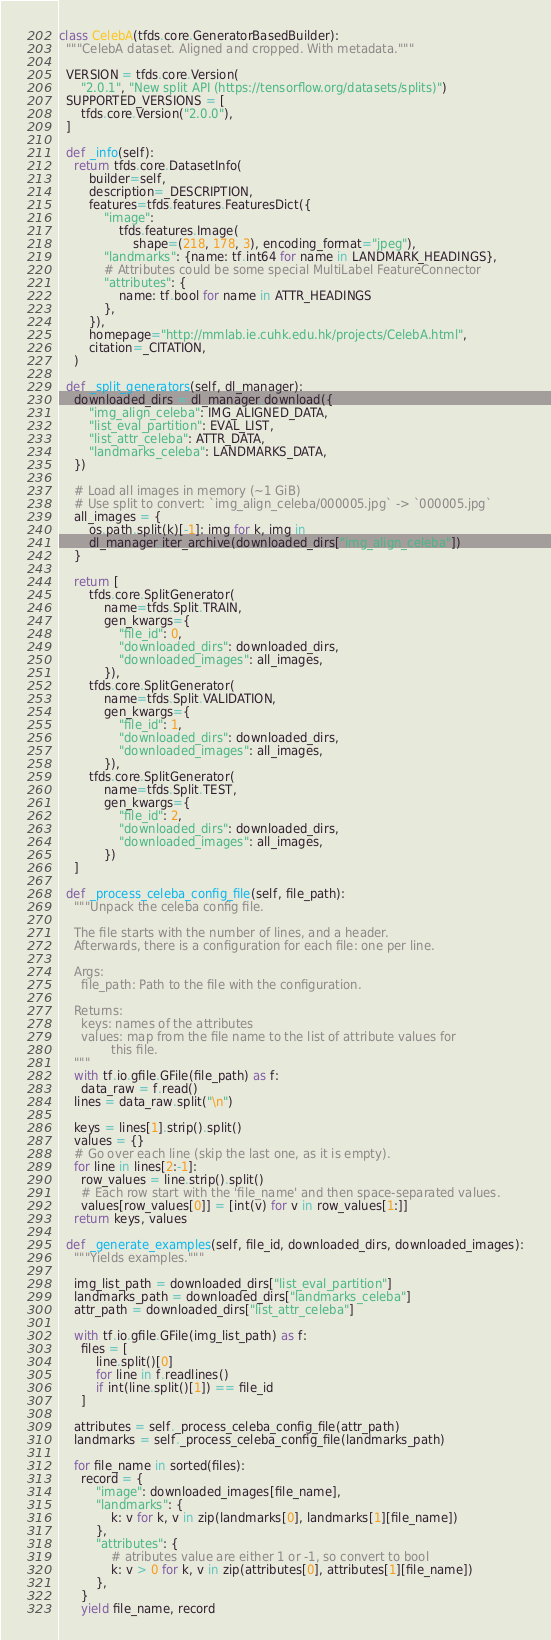Convert code to text. <code><loc_0><loc_0><loc_500><loc_500><_Python_>

class CelebA(tfds.core.GeneratorBasedBuilder):
  """CelebA dataset. Aligned and cropped. With metadata."""

  VERSION = tfds.core.Version(
      "2.0.1", "New split API (https://tensorflow.org/datasets/splits)")
  SUPPORTED_VERSIONS = [
      tfds.core.Version("2.0.0"),
  ]

  def _info(self):
    return tfds.core.DatasetInfo(
        builder=self,
        description=_DESCRIPTION,
        features=tfds.features.FeaturesDict({
            "image":
                tfds.features.Image(
                    shape=(218, 178, 3), encoding_format="jpeg"),
            "landmarks": {name: tf.int64 for name in LANDMARK_HEADINGS},
            # Attributes could be some special MultiLabel FeatureConnector
            "attributes": {
                name: tf.bool for name in ATTR_HEADINGS
            },
        }),
        homepage="http://mmlab.ie.cuhk.edu.hk/projects/CelebA.html",
        citation=_CITATION,
    )

  def _split_generators(self, dl_manager):
    downloaded_dirs = dl_manager.download({
        "img_align_celeba": IMG_ALIGNED_DATA,
        "list_eval_partition": EVAL_LIST,
        "list_attr_celeba": ATTR_DATA,
        "landmarks_celeba": LANDMARKS_DATA,
    })

    # Load all images in memory (~1 GiB)
    # Use split to convert: `img_align_celeba/000005.jpg` -> `000005.jpg`
    all_images = {
        os.path.split(k)[-1]: img for k, img in
        dl_manager.iter_archive(downloaded_dirs["img_align_celeba"])
    }

    return [
        tfds.core.SplitGenerator(
            name=tfds.Split.TRAIN,
            gen_kwargs={
                "file_id": 0,
                "downloaded_dirs": downloaded_dirs,
                "downloaded_images": all_images,
            }),
        tfds.core.SplitGenerator(
            name=tfds.Split.VALIDATION,
            gen_kwargs={
                "file_id": 1,
                "downloaded_dirs": downloaded_dirs,
                "downloaded_images": all_images,
            }),
        tfds.core.SplitGenerator(
            name=tfds.Split.TEST,
            gen_kwargs={
                "file_id": 2,
                "downloaded_dirs": downloaded_dirs,
                "downloaded_images": all_images,
            })
    ]

  def _process_celeba_config_file(self, file_path):
    """Unpack the celeba config file.

    The file starts with the number of lines, and a header.
    Afterwards, there is a configuration for each file: one per line.

    Args:
      file_path: Path to the file with the configuration.

    Returns:
      keys: names of the attributes
      values: map from the file name to the list of attribute values for
              this file.
    """
    with tf.io.gfile.GFile(file_path) as f:
      data_raw = f.read()
    lines = data_raw.split("\n")

    keys = lines[1].strip().split()
    values = {}
    # Go over each line (skip the last one, as it is empty).
    for line in lines[2:-1]:
      row_values = line.strip().split()
      # Each row start with the 'file_name' and then space-separated values.
      values[row_values[0]] = [int(v) for v in row_values[1:]]
    return keys, values

  def _generate_examples(self, file_id, downloaded_dirs, downloaded_images):
    """Yields examples."""

    img_list_path = downloaded_dirs["list_eval_partition"]
    landmarks_path = downloaded_dirs["landmarks_celeba"]
    attr_path = downloaded_dirs["list_attr_celeba"]

    with tf.io.gfile.GFile(img_list_path) as f:
      files = [
          line.split()[0]
          for line in f.readlines()
          if int(line.split()[1]) == file_id
      ]

    attributes = self._process_celeba_config_file(attr_path)
    landmarks = self._process_celeba_config_file(landmarks_path)

    for file_name in sorted(files):
      record = {
          "image": downloaded_images[file_name],
          "landmarks": {
              k: v for k, v in zip(landmarks[0], landmarks[1][file_name])
          },
          "attributes": {
              # atributes value are either 1 or -1, so convert to bool
              k: v > 0 for k, v in zip(attributes[0], attributes[1][file_name])
          },
      }
      yield file_name, record
</code> 